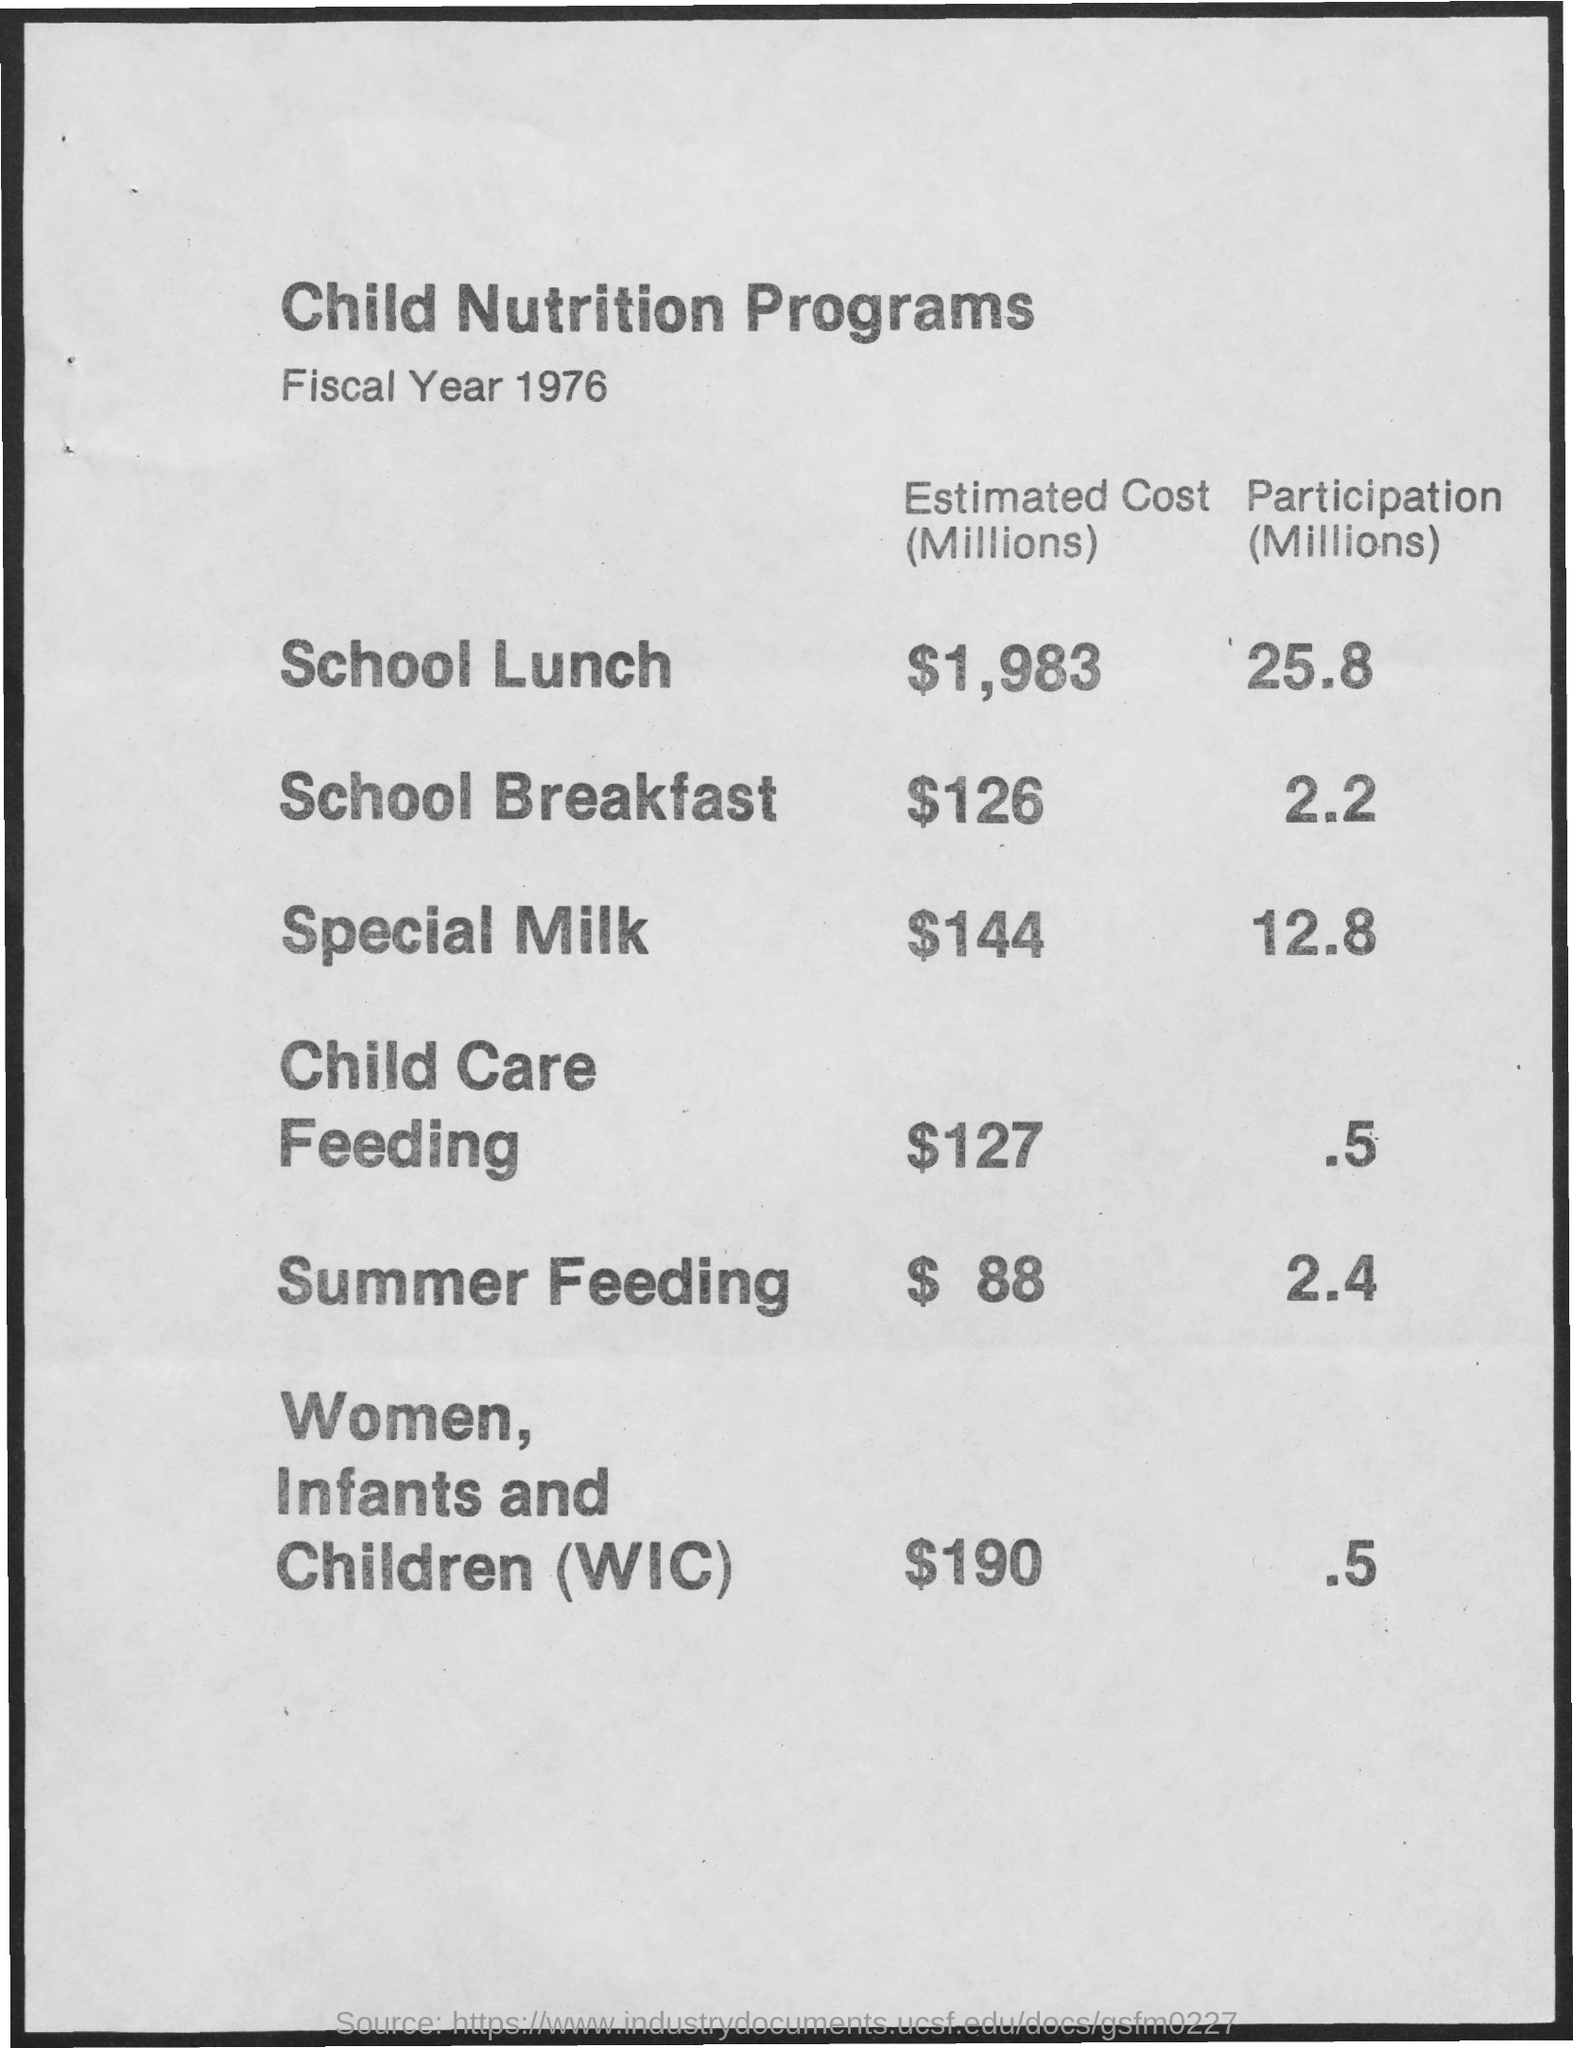Give some essential details in this illustration. The participation in the school lunch program was 25.8 million in a certain year. The participation in school breakfast, expressed in millions, is 2.2. The estimated cost for Women, Infants and Children (WIC) is approximately $190 million. The estimated cost (in millions) for special milk is $144. The estimated cost for school lunch is $1,983 for each million. 